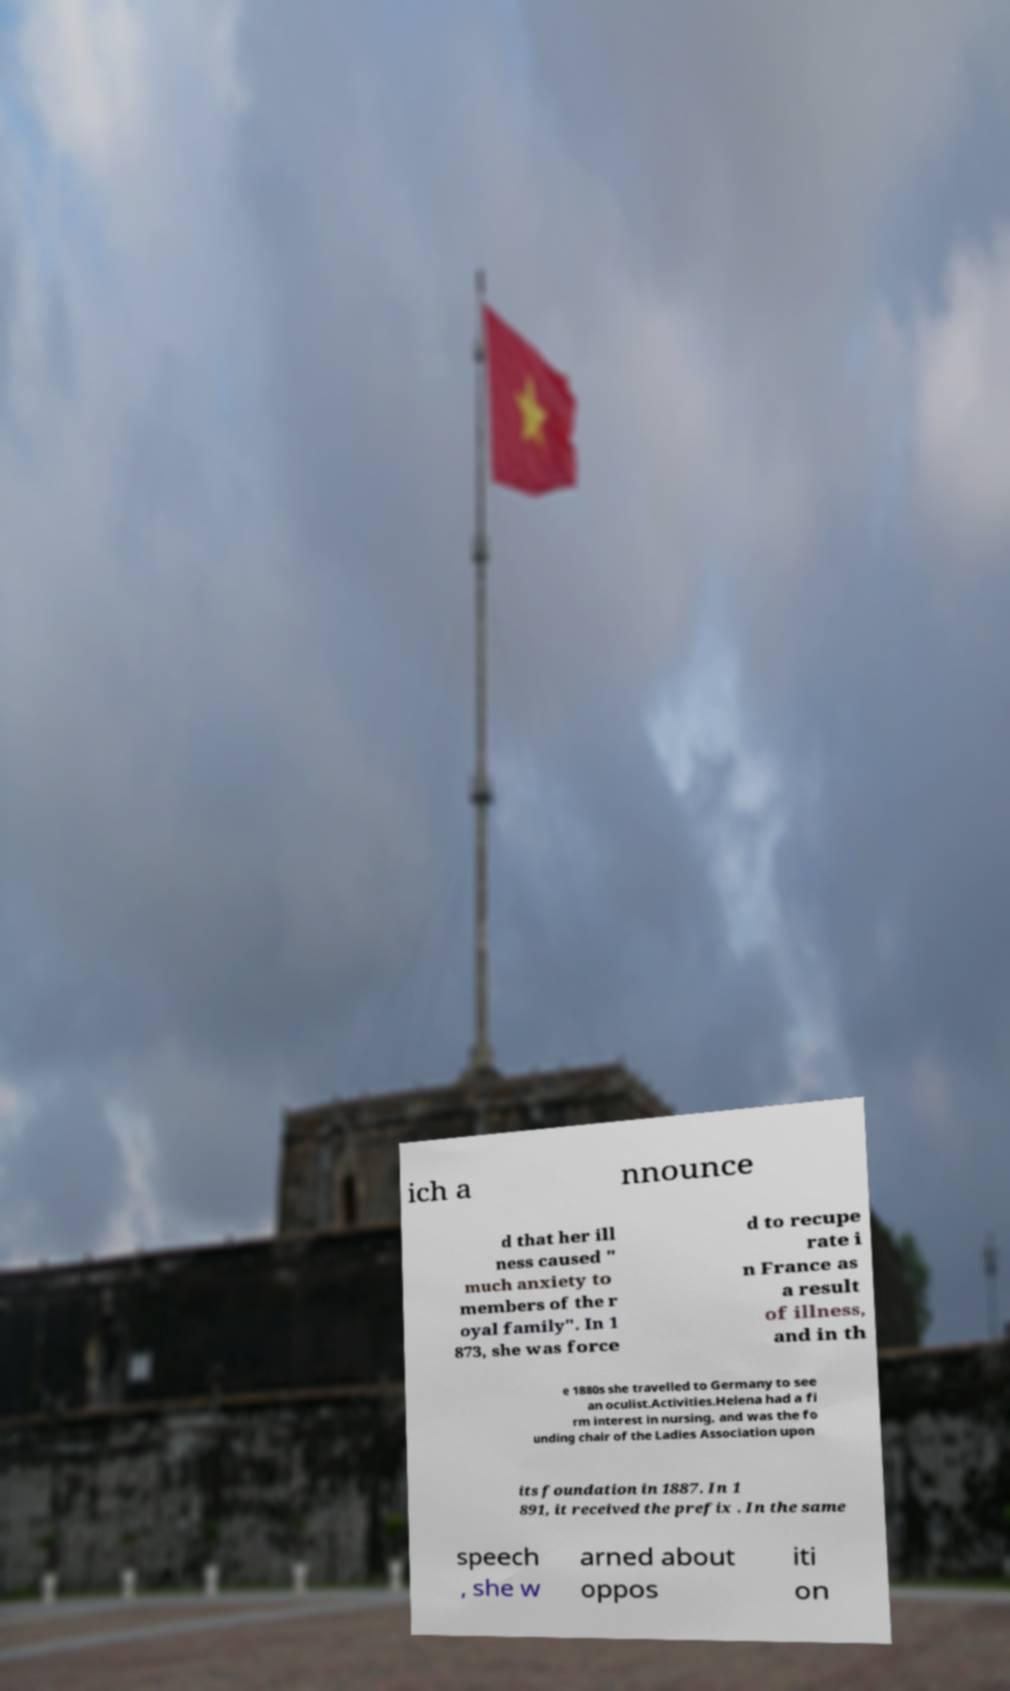Please read and relay the text visible in this image. What does it say? ich a nnounce d that her ill ness caused " much anxiety to members of the r oyal family". In 1 873, she was force d to recupe rate i n France as a result of illness, and in th e 1880s she travelled to Germany to see an oculist.Activities.Helena had a fi rm interest in nursing, and was the fo unding chair of the Ladies Association upon its foundation in 1887. In 1 891, it received the prefix . In the same speech , she w arned about oppos iti on 